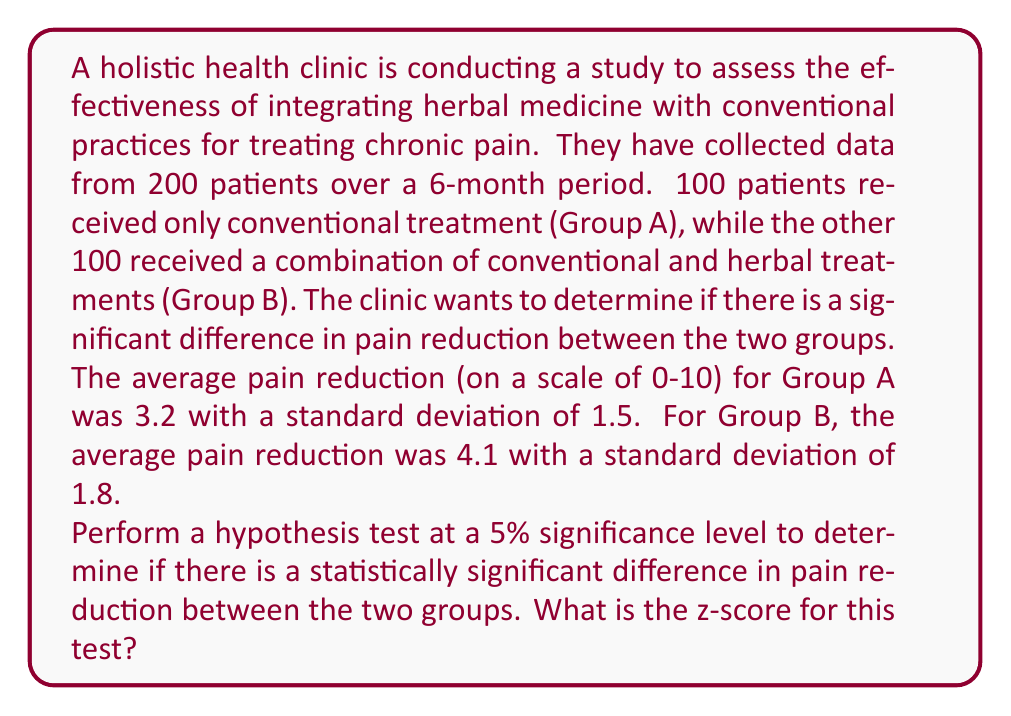Provide a solution to this math problem. To solve this problem, we'll use a two-sample z-test for comparing means. We'll follow these steps:

1. State the null and alternative hypotheses:
   $H_0: \mu_A = \mu_B$ (no difference in pain reduction)
   $H_a: \mu_A \neq \mu_B$ (there is a difference in pain reduction)

2. Calculate the standard error of the difference between means:
   $$SE = \sqrt{\frac{s_A^2}{n_A} + \frac{s_B^2}{n_B}}$$
   where $s_A$ and $s_B$ are the standard deviations, and $n_A$ and $n_B$ are the sample sizes.

   $$SE = \sqrt{\frac{1.5^2}{100} + \frac{1.8^2}{100}} = \sqrt{0.0225 + 0.0324} = \sqrt{0.0549} = 0.2343$$

3. Calculate the z-score:
   $$z = \frac{(\bar{x}_B - \bar{x}_A) - (\mu_B - \mu_A)}{SE}$$
   where $\bar{x}_A$ and $\bar{x}_B$ are the sample means, and $(\mu_B - \mu_A)$ is 0 under the null hypothesis.

   $$z = \frac{(4.1 - 3.2) - 0}{0.2343} = \frac{0.9}{0.2343} = 3.8413$$

4. The z-score is 3.8413, which is greater than the critical value of 1.96 for a two-tailed test at the 5% significance level. This suggests that we would reject the null hypothesis and conclude that there is a statistically significant difference in pain reduction between the two groups.
Answer: The z-score for the hypothesis test is 3.8413. 